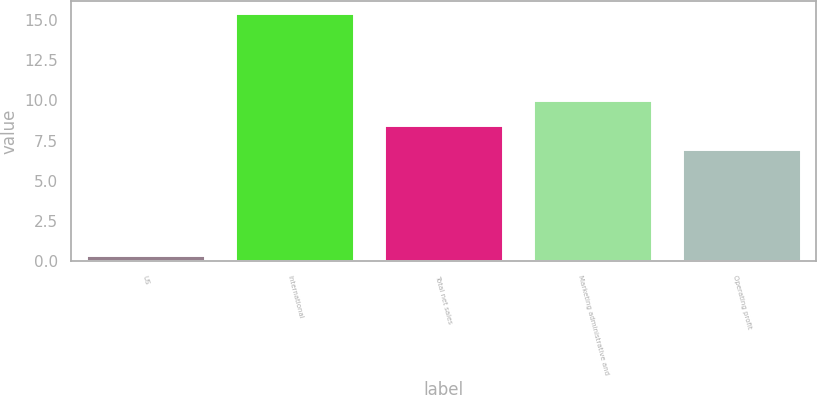<chart> <loc_0><loc_0><loc_500><loc_500><bar_chart><fcel>US<fcel>International<fcel>Total net sales<fcel>Marketing administrative and<fcel>Operating profit<nl><fcel>0.4<fcel>15.4<fcel>8.5<fcel>10<fcel>7<nl></chart> 